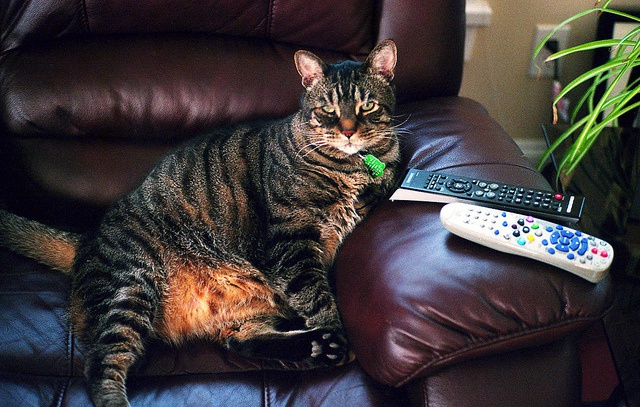Describe the objects in this image and their specific colors. I can see couch in black, gray, and purple tones, cat in black and gray tones, potted plant in black, green, darkgreen, and olive tones, remote in black, white, darkgray, and blue tones, and remote in black, white, blue, and teal tones in this image. 